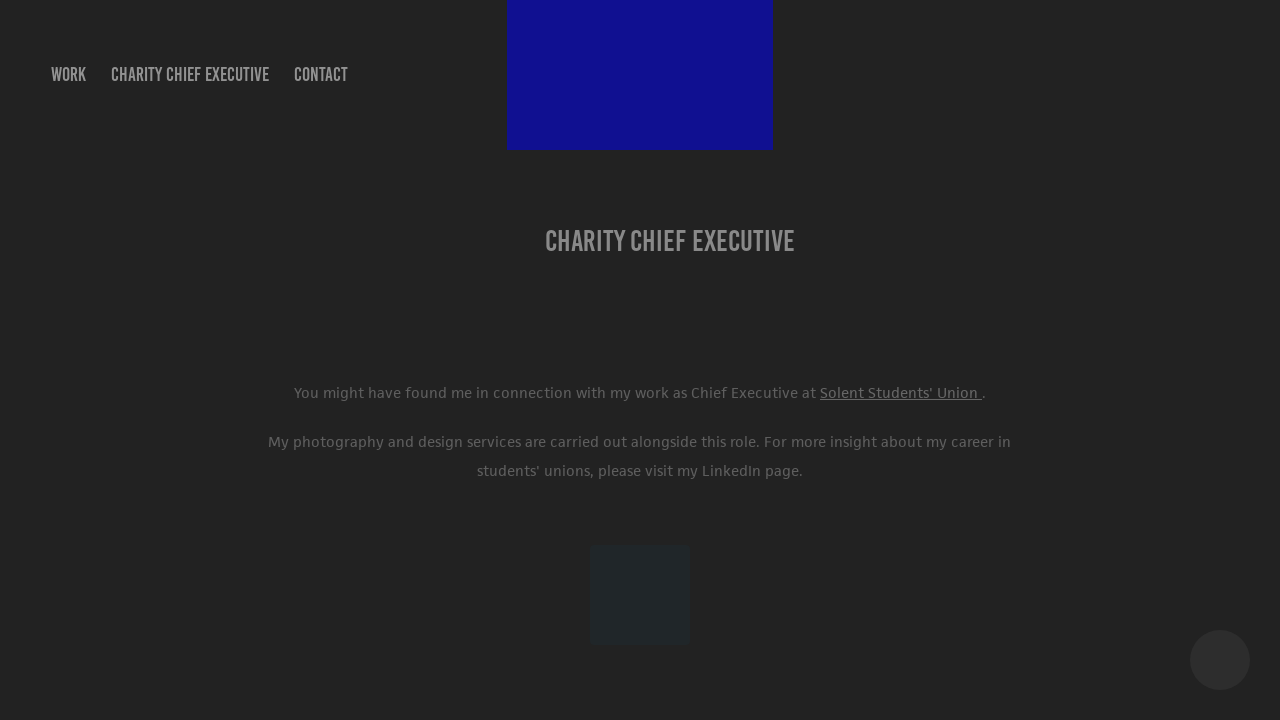Can you explain what sort of information is presented on this webpage? This webpage appears to be a professional portfolio or a personal site of an individual detailing their role as a Charity Chief Executive at Solent Students' Union. It mentions secondary engagement in photography and design, suggesting a multifaceted professional involvement. 